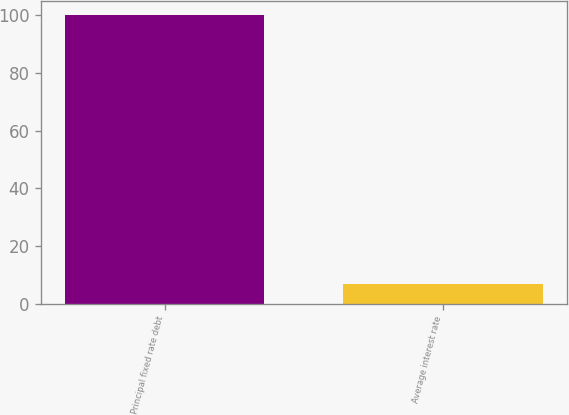Convert chart to OTSL. <chart><loc_0><loc_0><loc_500><loc_500><bar_chart><fcel>Principal fixed rate debt<fcel>Average interest rate<nl><fcel>100<fcel>6.98<nl></chart> 